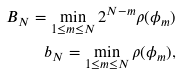<formula> <loc_0><loc_0><loc_500><loc_500>B _ { N } = \min _ { 1 \leq m \leq N } 2 ^ { N - m } \rho ( \phi _ { m } ) \\ b _ { N } = \min _ { 1 \leq m \leq N } \rho ( \phi _ { m } ) ,</formula> 